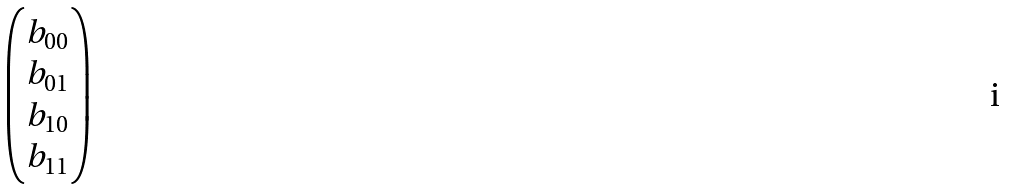Convert formula to latex. <formula><loc_0><loc_0><loc_500><loc_500>\begin{pmatrix} b _ { 0 0 } \\ b _ { 0 1 } \\ b _ { 1 0 } \\ b _ { 1 1 } \\ \end{pmatrix}</formula> 